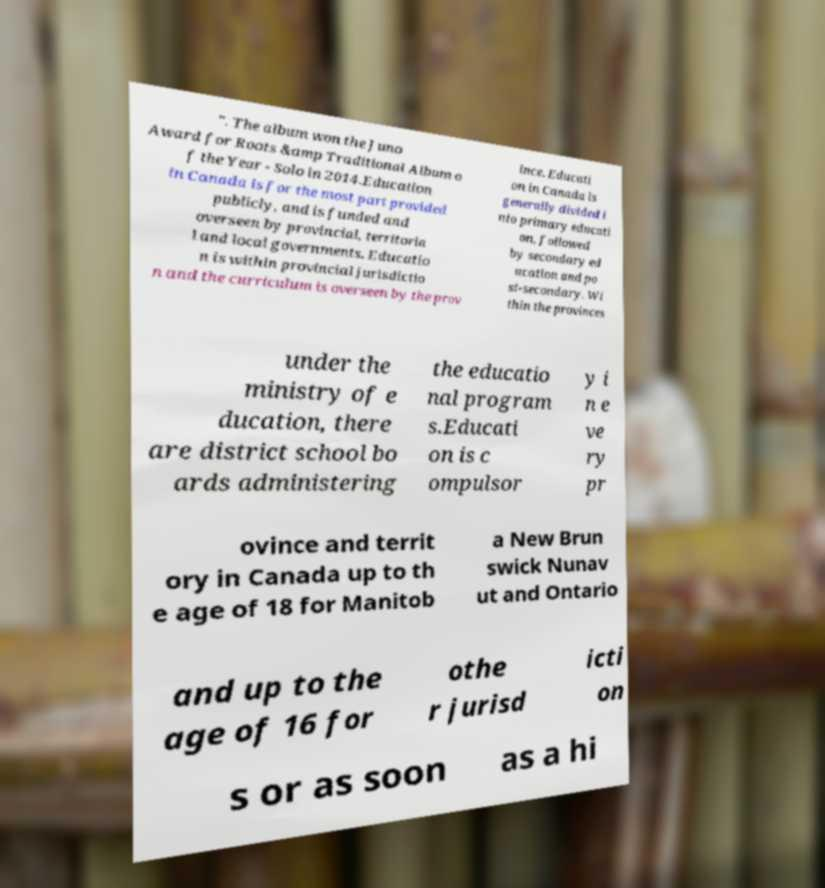What messages or text are displayed in this image? I need them in a readable, typed format. ". The album won the Juno Award for Roots &amp Traditional Album o f the Year - Solo in 2014.Education in Canada is for the most part provided publicly, and is funded and overseen by provincial, territoria l and local governments. Educatio n is within provincial jurisdictio n and the curriculum is overseen by the prov ince. Educati on in Canada is generally divided i nto primary educati on, followed by secondary ed ucation and po st-secondary. Wi thin the provinces under the ministry of e ducation, there are district school bo ards administering the educatio nal program s.Educati on is c ompulsor y i n e ve ry pr ovince and territ ory in Canada up to th e age of 18 for Manitob a New Brun swick Nunav ut and Ontario and up to the age of 16 for othe r jurisd icti on s or as soon as a hi 